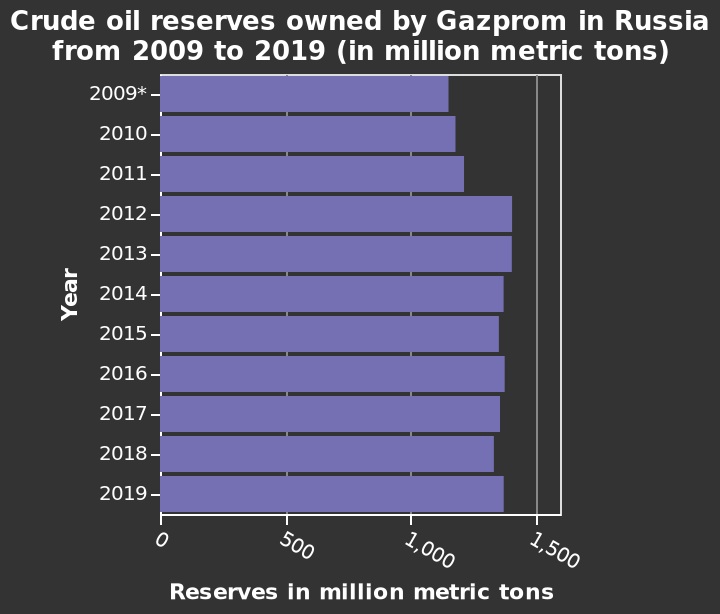<image>
What company owns the crude oil reserves mentioned in the figure?  Gazprom owns the crude oil reserves mentioned in the figure. In what country are the crude oil reserves owned by Gazprom located?  The crude oil reserves owned by Gazprom are located in Russia. please summary the statistics and relations of the chart 2012 saw a significant increase in crude oil reserves with numbers staying relatively stable since then. 